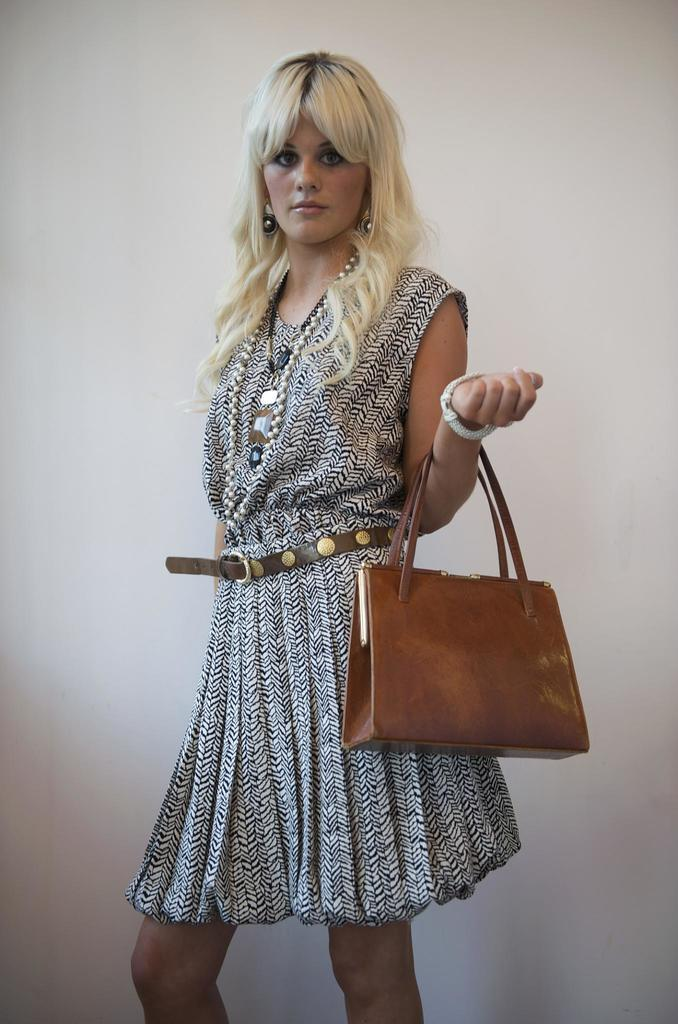What is the main subject of the image? The main subject of the image is a woman. What is the woman holding in the image? The woman is holding a handbag. What can be observed about the woman's hair? The woman's hair is white in color. What type of clothing is the woman wearing? The woman is wearing a skirt. What additional detail can be noted about the skirt? The skirt has a belt. Where is the goose located in the image? There is no goose present in the image. Can you describe the snail's shell in the image? There is no snail present in the image, so it is not possible to describe its shell. 